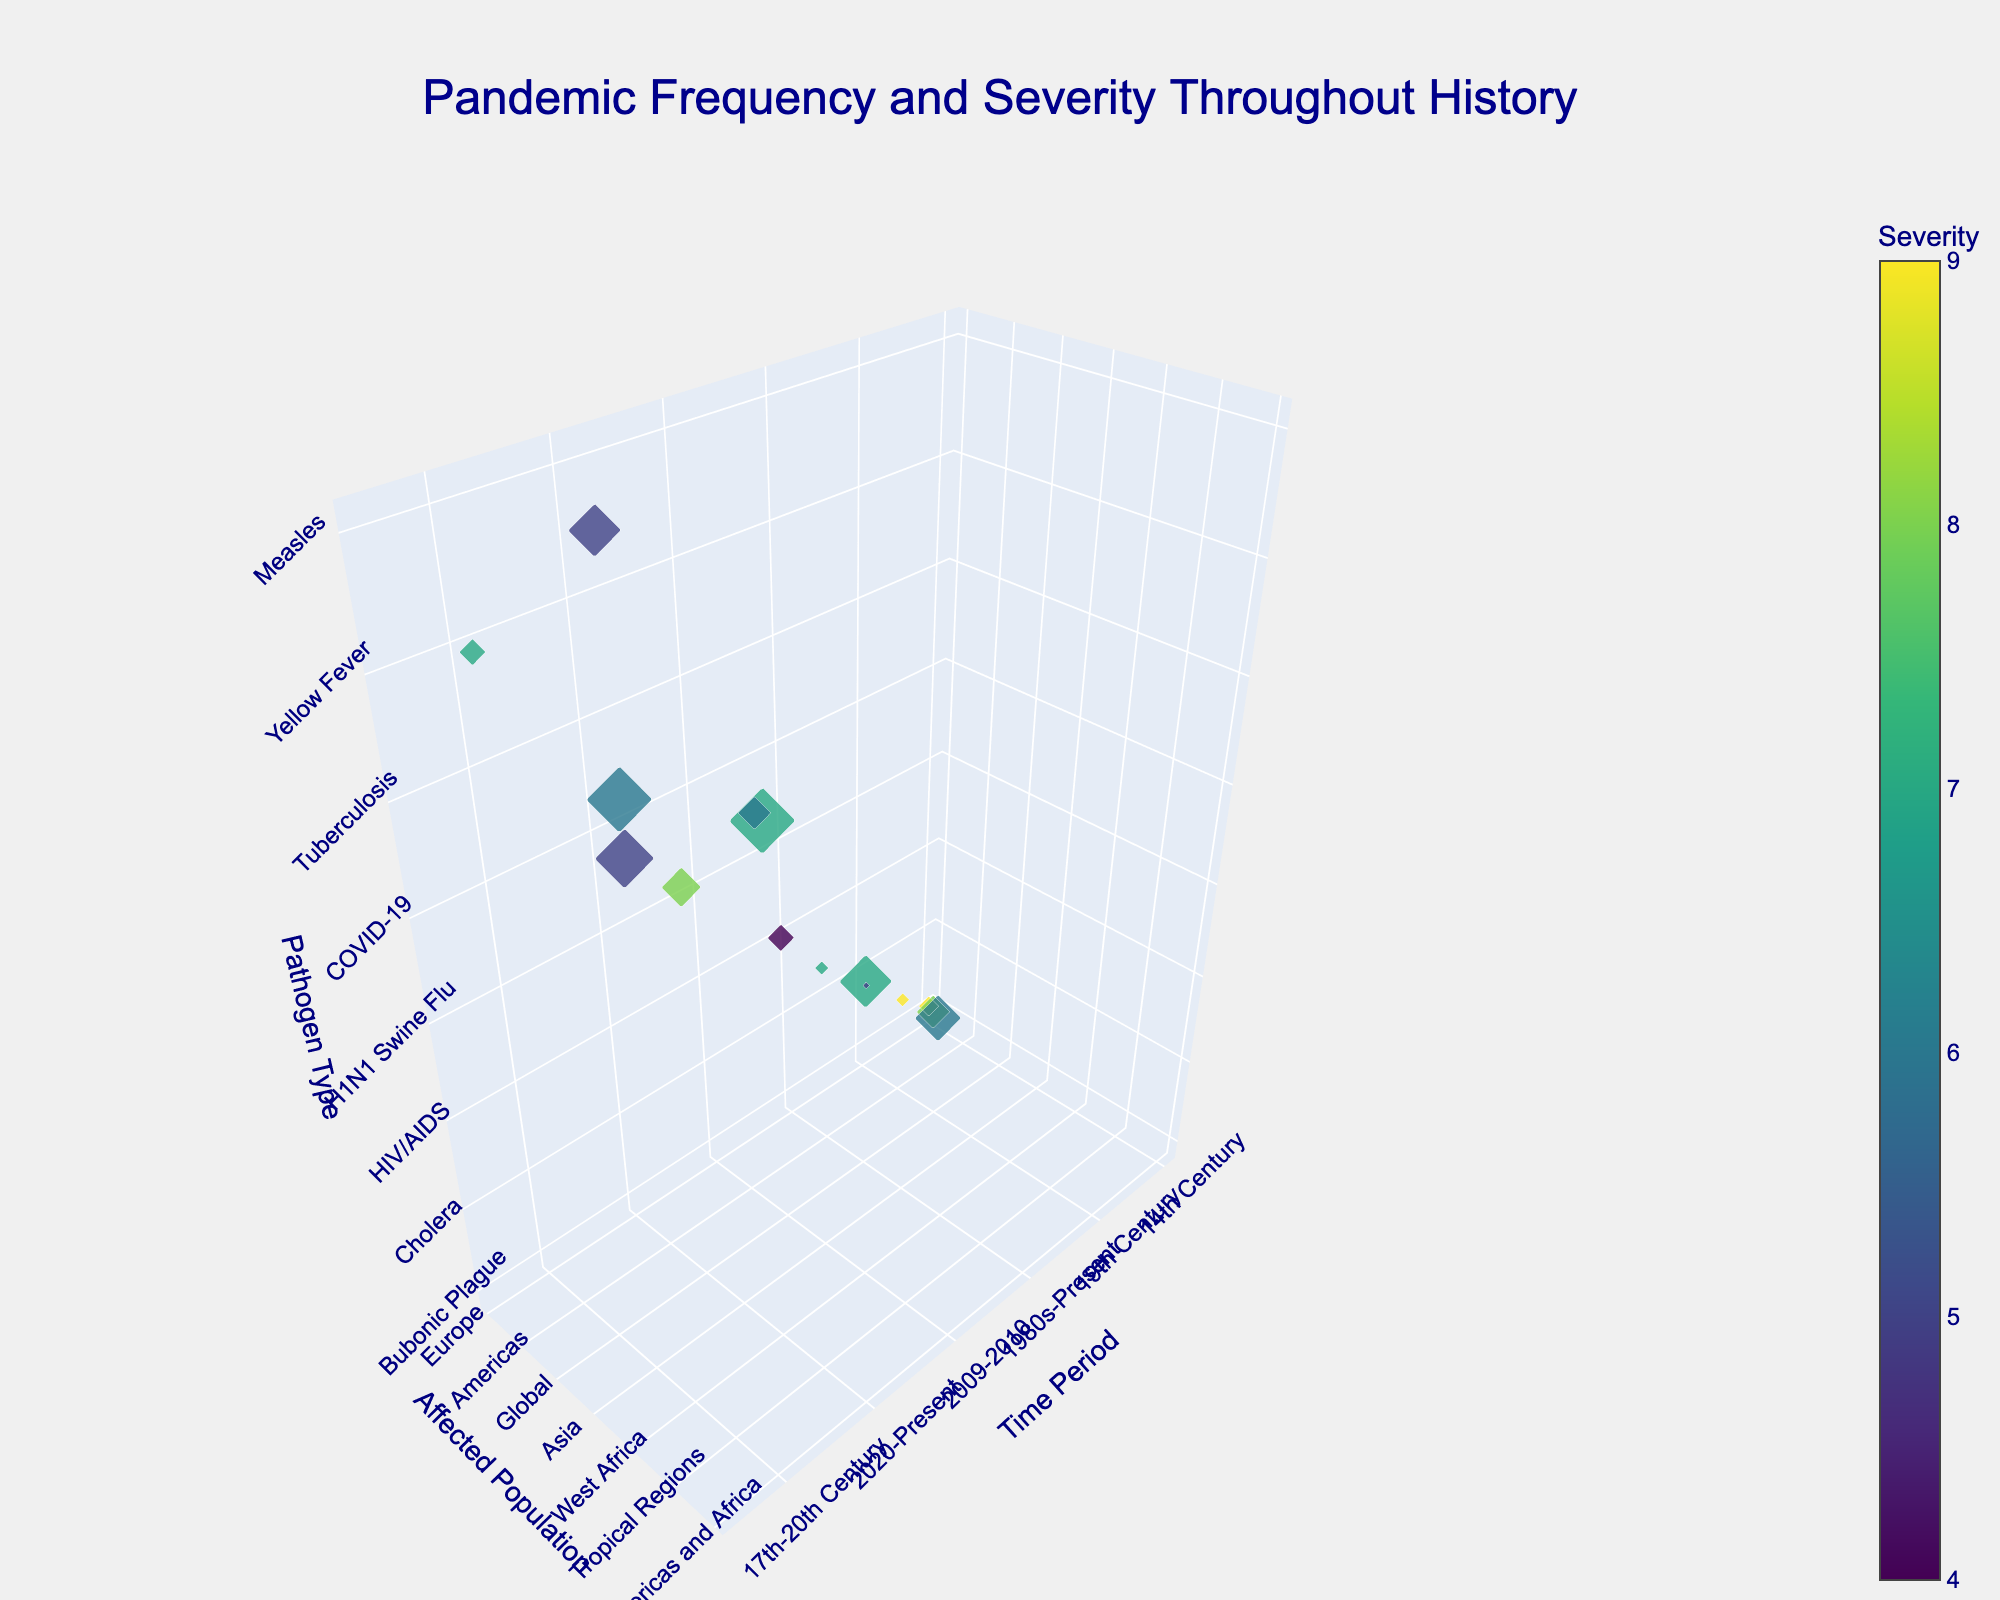What's the title of the figure? The title is usually displayed at the top of the figure and in this case, it is specified in the code under 'title'.
Answer: Pandemic Frequency and Severity Throughout History What pathogen type affects the most diverse regions? By looking at the 'Affected Population' axis and noting the different regions affected by each pathogen, you can see that the pathogen types affecting 'Global' populations are the most diverse.
Answer: Tuberculosis Which pandemic has the highest severity rating? The 'Severity' value is directly indicated in both the color intensity on the volume plot and the scattered marker data. The highest value noted is 9.
Answer: Bubonic Plague and Spanish Flu Which disease has the highest frequency of occurrence? Each scatter point's 'Frequency' is represented by the size of the marker. The largest marker sizes denote the highest frequency, which is directly labeled.
Answer: Tuberculosis and Malaria Comparing COVID-19 and Spanish Flu, which one has higher severity and how do their frequencies compare? Check the severity ratings and frequencies for both the COVID-19 and Spanish Flu markers. COVID-19 has a severity of 8 and frequency of 6, whereas Spanish Flu has a severity of 9 and frequency of 2.
Answer: Spanish Flu has higher severity, COVID-19 has higher frequency What's the average severity of pandemics that affected global populations? Identify pandemics affecting 'Global' and compute their severity ratings: Cholera (6), Spanish Flu (9), HIV/AIDS (7), H1N1 Swine Flu (4), COVID-19 (8), Typhoid (5), Tuberculosis (6), Measles (5). Average = (6+9+7+4+8+5+6+5)/8 = 6.25
Answer: 6.25 Which pathogen type has the least frequency despite having a high severity? Look for the pathogen type with a high severity rating but small frequency marker size. SARS and Spanish Flu have high severities (5 and 9 respectively) paired with low frequencies (1 and 2 respectively).
Answer: SARS Arrange the pandemics affecting the Americas in ascending order of frequency. Identify pathogen types affecting 'Americas' and list their frequencies. Smallpox (5), Yellow Fever (5). Both have the same frequency. Order: Smallpox, Yellow Fever.
Answer: Smallpox, Yellow Fever Which pandemic affected a single region but had a relatively high severity? Review pandemics where 'Affected Population' shows a specific region rather than 'Global'. Ebola (West Africa, severity 7) fits this description.
Answer: Ebola 